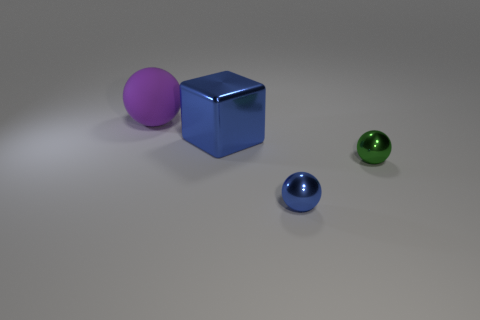Is there anything else that is the same material as the purple sphere?
Offer a very short reply. No. What number of tiny shiny balls have the same color as the large block?
Your answer should be very brief. 1. The other small metallic object that is the same shape as the tiny blue shiny object is what color?
Provide a succinct answer. Green. There is a object that is both behind the green thing and in front of the big purple object; what material is it made of?
Keep it short and to the point. Metal. Is the material of the blue object left of the tiny blue metal ball the same as the small sphere that is behind the blue shiny ball?
Your answer should be compact. Yes. How big is the blue metallic ball?
Keep it short and to the point. Small. There is a green metal object that is the same shape as the big matte object; what size is it?
Make the answer very short. Small. There is a large purple matte sphere; what number of big objects are on the right side of it?
Keep it short and to the point. 1. What is the color of the ball that is behind the large object on the right side of the purple thing?
Your answer should be compact. Purple. Is there anything else that is the same shape as the matte object?
Make the answer very short. Yes. 